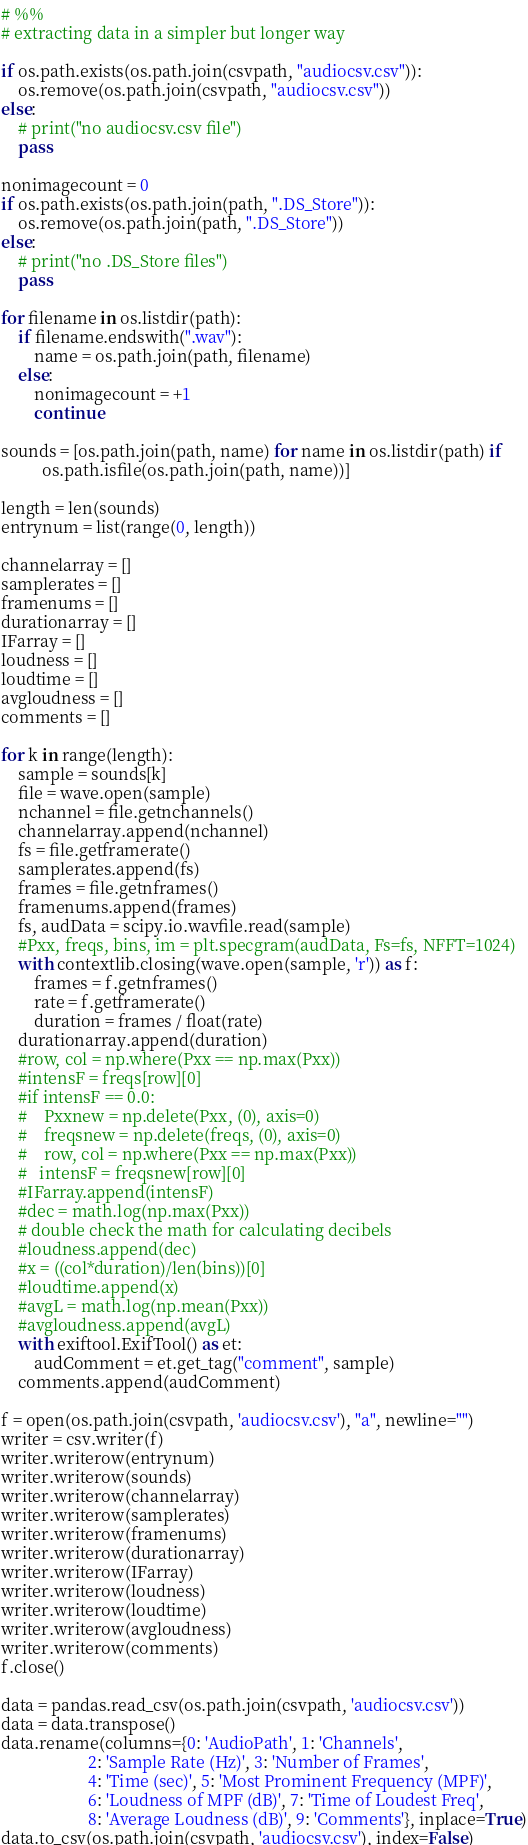<code> <loc_0><loc_0><loc_500><loc_500><_Python_>
# %%
# extracting data in a simpler but longer way

if os.path.exists(os.path.join(csvpath, "audiocsv.csv")):
    os.remove(os.path.join(csvpath, "audiocsv.csv"))
else:
    # print("no audiocsv.csv file")
    pass

nonimagecount = 0
if os.path.exists(os.path.join(path, ".DS_Store")):
    os.remove(os.path.join(path, ".DS_Store"))
else:
    # print("no .DS_Store files")
    pass

for filename in os.listdir(path):
    if filename.endswith(".wav"):
        name = os.path.join(path, filename)
    else:
        nonimagecount = +1
        continue

sounds = [os.path.join(path, name) for name in os.listdir(path) if
          os.path.isfile(os.path.join(path, name))]

length = len(sounds)
entrynum = list(range(0, length))

channelarray = []
samplerates = []
framenums = []
durationarray = []
IFarray = []
loudness = []
loudtime = []
avgloudness = []
comments = []

for k in range(length):
    sample = sounds[k]
    file = wave.open(sample)
    nchannel = file.getnchannels()
    channelarray.append(nchannel)
    fs = file.getframerate()
    samplerates.append(fs)
    frames = file.getnframes()
    framenums.append(frames)
    fs, audData = scipy.io.wavfile.read(sample)
    #Pxx, freqs, bins, im = plt.specgram(audData, Fs=fs, NFFT=1024)
    with contextlib.closing(wave.open(sample, 'r')) as f:
        frames = f.getnframes()
        rate = f.getframerate()
        duration = frames / float(rate)
    durationarray.append(duration)
    #row, col = np.where(Pxx == np.max(Pxx))
    #intensF = freqs[row][0]
    #if intensF == 0.0:
    #    Pxxnew = np.delete(Pxx, (0), axis=0)
    #    freqsnew = np.delete(freqs, (0), axis=0)
    #    row, col = np.where(Pxx == np.max(Pxx))
    #   intensF = freqsnew[row][0]
    #IFarray.append(intensF)
    #dec = math.log(np.max(Pxx))
    # double check the math for calculating decibels
    #loudness.append(dec)
    #x = ((col*duration)/len(bins))[0]
    #loudtime.append(x)
    #avgL = math.log(np.mean(Pxx))
    #avgloudness.append(avgL)
    with exiftool.ExifTool() as et:
        audComment = et.get_tag("comment", sample)
    comments.append(audComment)

f = open(os.path.join(csvpath, 'audiocsv.csv'), "a", newline="")
writer = csv.writer(f)
writer.writerow(entrynum)
writer.writerow(sounds)
writer.writerow(channelarray)
writer.writerow(samplerates)
writer.writerow(framenums)
writer.writerow(durationarray)
writer.writerow(IFarray)
writer.writerow(loudness)
writer.writerow(loudtime)
writer.writerow(avgloudness)
writer.writerow(comments)
f.close()

data = pandas.read_csv(os.path.join(csvpath, 'audiocsv.csv'))
data = data.transpose()
data.rename(columns={0: 'AudioPath', 1: 'Channels',
                     2: 'Sample Rate (Hz)', 3: 'Number of Frames',
                     4: 'Time (sec)', 5: 'Most Prominent Frequency (MPF)',
                     6: 'Loudness of MPF (dB)', 7: 'Time of Loudest Freq',
                     8: 'Average Loudness (dB)', 9: 'Comments'}, inplace=True)
data.to_csv(os.path.join(csvpath, 'audiocsv.csv'), index=False)
</code> 